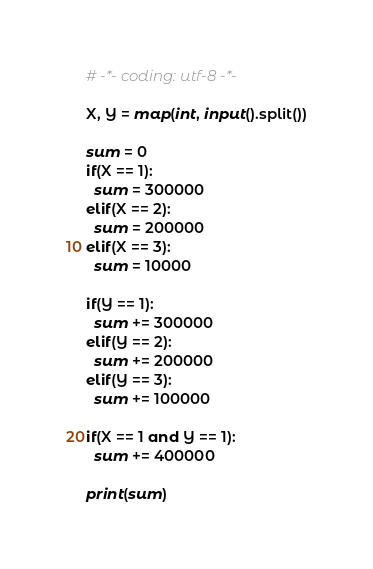<code> <loc_0><loc_0><loc_500><loc_500><_Python_># -*- coding: utf-8 -*-

X, Y = map(int, input().split())

sum = 0
if(X == 1):
  sum = 300000
elif(X == 2):
  sum = 200000
elif(X == 3):
  sum = 10000

if(Y == 1):
  sum += 300000
elif(Y == 2):
  sum += 200000
elif(Y == 3):
  sum += 100000

if(X == 1 and Y == 1):
  sum += 400000

print(sum)
</code> 